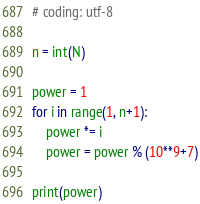Convert code to text. <code><loc_0><loc_0><loc_500><loc_500><_Python_># coding: utf-8

n = int(N)

power = 1
for i in range(1, n+1):
    power *= i
    power = power % (10**9+7)

print(power)</code> 